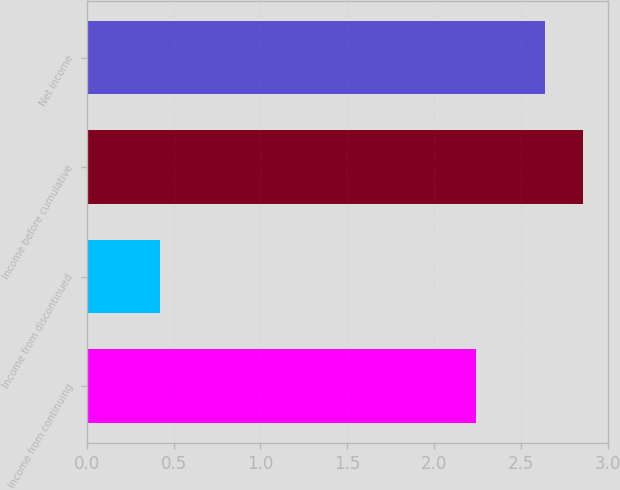Convert chart. <chart><loc_0><loc_0><loc_500><loc_500><bar_chart><fcel>Income from continuing<fcel>Income from discontinued<fcel>Income before cumulative<fcel>Net income<nl><fcel>2.24<fcel>0.42<fcel>2.86<fcel>2.64<nl></chart> 